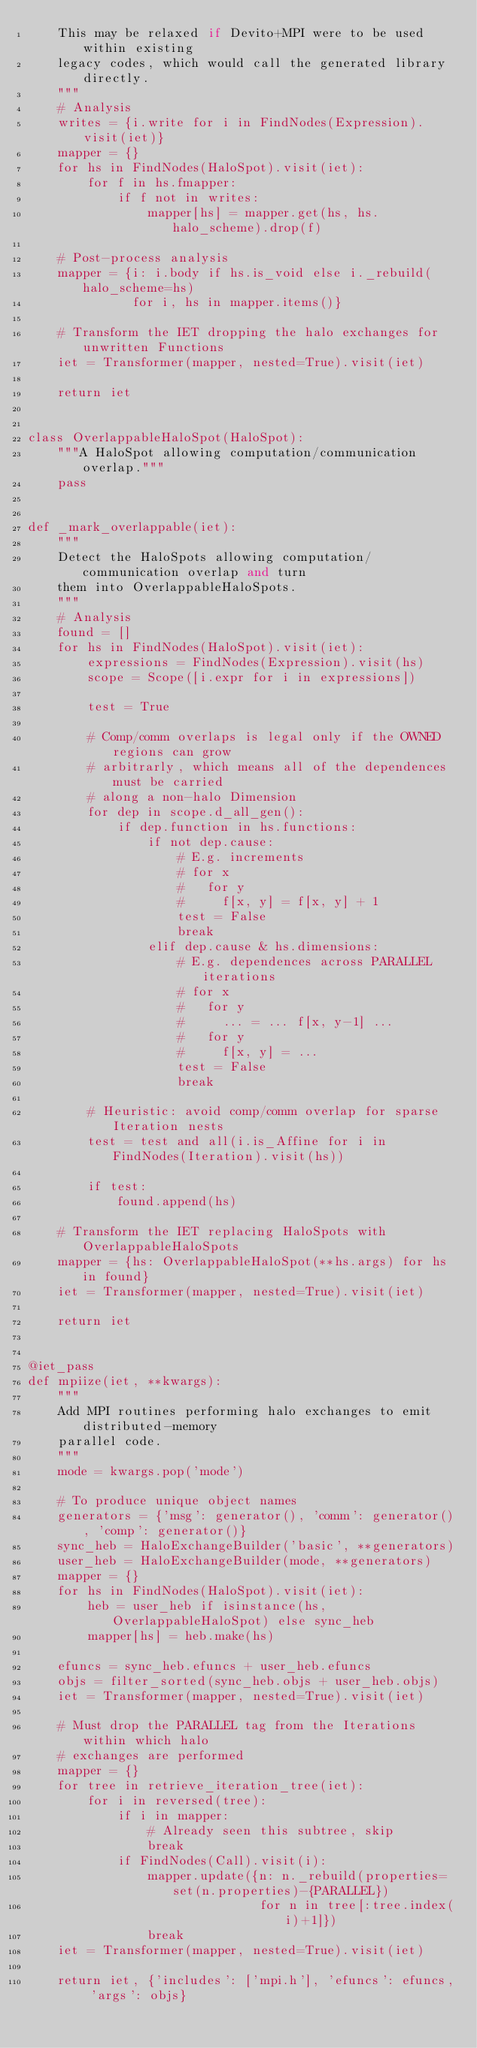Convert code to text. <code><loc_0><loc_0><loc_500><loc_500><_Python_>    This may be relaxed if Devito+MPI were to be used within existing
    legacy codes, which would call the generated library directly.
    """
    # Analysis
    writes = {i.write for i in FindNodes(Expression).visit(iet)}
    mapper = {}
    for hs in FindNodes(HaloSpot).visit(iet):
        for f in hs.fmapper:
            if f not in writes:
                mapper[hs] = mapper.get(hs, hs.halo_scheme).drop(f)

    # Post-process analysis
    mapper = {i: i.body if hs.is_void else i._rebuild(halo_scheme=hs)
              for i, hs in mapper.items()}

    # Transform the IET dropping the halo exchanges for unwritten Functions
    iet = Transformer(mapper, nested=True).visit(iet)

    return iet


class OverlappableHaloSpot(HaloSpot):
    """A HaloSpot allowing computation/communication overlap."""
    pass


def _mark_overlappable(iet):
    """
    Detect the HaloSpots allowing computation/communication overlap and turn
    them into OverlappableHaloSpots.
    """
    # Analysis
    found = []
    for hs in FindNodes(HaloSpot).visit(iet):
        expressions = FindNodes(Expression).visit(hs)
        scope = Scope([i.expr for i in expressions])

        test = True

        # Comp/comm overlaps is legal only if the OWNED regions can grow
        # arbitrarly, which means all of the dependences must be carried
        # along a non-halo Dimension
        for dep in scope.d_all_gen():
            if dep.function in hs.functions:
                if not dep.cause:
                    # E.g. increments
                    # for x
                    #   for y
                    #     f[x, y] = f[x, y] + 1
                    test = False
                    break
                elif dep.cause & hs.dimensions:
                    # E.g. dependences across PARALLEL iterations
                    # for x
                    #   for y
                    #     ... = ... f[x, y-1] ...
                    #   for y
                    #     f[x, y] = ...
                    test = False
                    break

        # Heuristic: avoid comp/comm overlap for sparse Iteration nests
        test = test and all(i.is_Affine for i in FindNodes(Iteration).visit(hs))

        if test:
            found.append(hs)

    # Transform the IET replacing HaloSpots with OverlappableHaloSpots
    mapper = {hs: OverlappableHaloSpot(**hs.args) for hs in found}
    iet = Transformer(mapper, nested=True).visit(iet)

    return iet


@iet_pass
def mpiize(iet, **kwargs):
    """
    Add MPI routines performing halo exchanges to emit distributed-memory
    parallel code.
    """
    mode = kwargs.pop('mode')

    # To produce unique object names
    generators = {'msg': generator(), 'comm': generator(), 'comp': generator()}
    sync_heb = HaloExchangeBuilder('basic', **generators)
    user_heb = HaloExchangeBuilder(mode, **generators)
    mapper = {}
    for hs in FindNodes(HaloSpot).visit(iet):
        heb = user_heb if isinstance(hs, OverlappableHaloSpot) else sync_heb
        mapper[hs] = heb.make(hs)

    efuncs = sync_heb.efuncs + user_heb.efuncs
    objs = filter_sorted(sync_heb.objs + user_heb.objs)
    iet = Transformer(mapper, nested=True).visit(iet)

    # Must drop the PARALLEL tag from the Iterations within which halo
    # exchanges are performed
    mapper = {}
    for tree in retrieve_iteration_tree(iet):
        for i in reversed(tree):
            if i in mapper:
                # Already seen this subtree, skip
                break
            if FindNodes(Call).visit(i):
                mapper.update({n: n._rebuild(properties=set(n.properties)-{PARALLEL})
                               for n in tree[:tree.index(i)+1]})
                break
    iet = Transformer(mapper, nested=True).visit(iet)

    return iet, {'includes': ['mpi.h'], 'efuncs': efuncs, 'args': objs}
</code> 